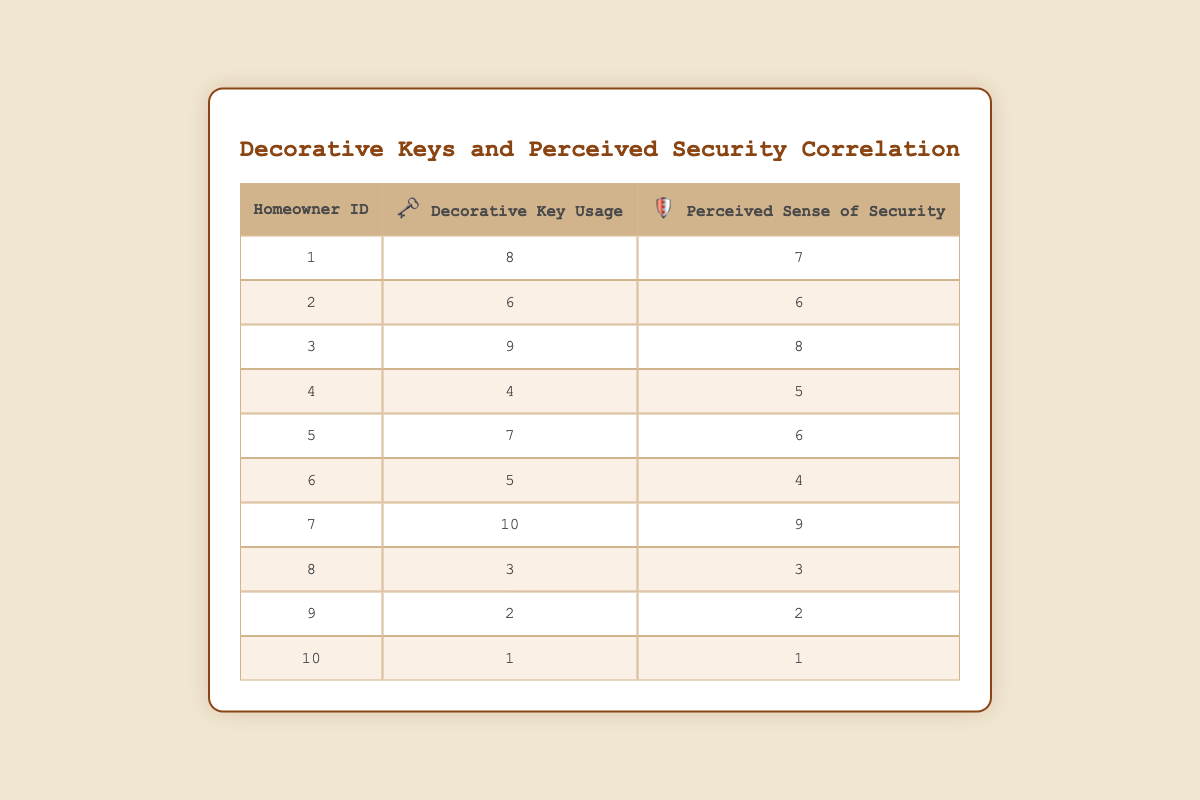What is the Decorative Key Usage for Homeowner ID 5? From the table, we can find Homeowner ID 5 and look at the corresponding value in the Decorative Key Usage column, which is 7.
Answer: 7 What is the Perceived Sense of Security for Homeowner ID 3? By locating Homeowner ID 3 in the table, we can see that the Perceived Sense of Security value in that row is 8.
Answer: 8 Which homeowner has the highest Decorative Key Usage? We can read through the rows and find that Homeowner ID 7 has the highest value of Decorative Key Usage, which is 10.
Answer: Homeowner ID 7 Is the Perceived Sense of Security higher for Homeowners with Decorative Key Usage over 6? By checking Homeowners with a Decorative Key Usage greater than 6 (IDs 1, 3, 5, and 7), we can confirm that all these homeowners have a Perceived Sense of Security that is equal to or higher than their usage values.
Answer: Yes What is the difference in Perceived Sense of Security between the highest and lowest Decorative Key Usage? The highest Decorative Key Usage is 10 (Homeowner ID 7 with a Perceived Sense of Security of 9), and the lowest is 1 (Homeowner ID 10 with a Perceived Sense of Security of 1). Thus, the difference is 9 - 1 = 8.
Answer: 8 What is the average Decorative Key Usage among all homeowners? We sum the Decorative Key Usage (8 + 6 + 9 + 4 + 7 + 5 + 10 + 3 + 2 + 1) = 55. There are 10 homeowners, so the average is 55/10 = 5.5.
Answer: 5.5 What is the average Perceived Sense of Security for homeowners using fewer than 5 decorative keys? The homeowners with fewer than 5 decorative keys are IDs 6, 8, 9, and 10. Their Perceived Sense of Security values are 4, 3, 2, and 1 respectively, summing up to 10. There are 4 homeowners, so the average is 10/4 = 2.5.
Answer: 2.5 Does higher Decorative Key Usage correlate with higher Perceived Sense of Security? Observing the table, as Decorative Key Usage increases, Perceived Sense of Security also tends to increase (e.g., ID 1 has 8 and 7, ID 7 has 10 and 9).
Answer: Yes Which homeowner has a Decorative Key Usage of 2, and what is their Perceived Sense of Security? Homeowner ID 9 has a Decorative Key Usage of 2. The corresponding Perceived Sense of Security for this homeowner is also 2.
Answer: Homeowner ID 9, Security 2 